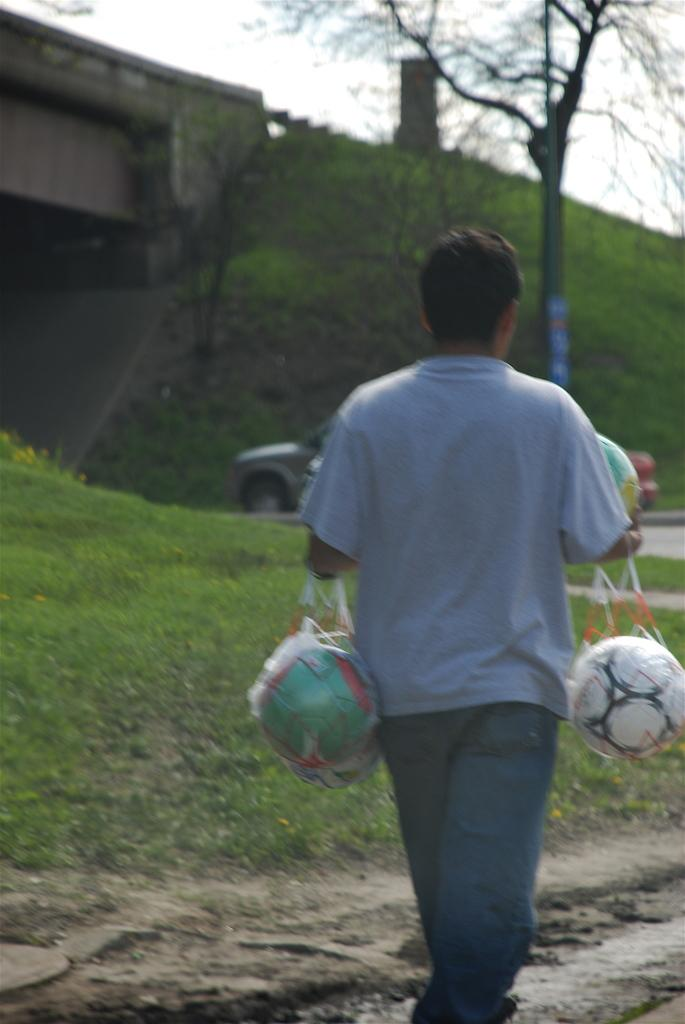What is the person in the image doing? The person is walking in the image. What is the person holding while walking? The person is holding a ball. What type of terrain is visible in the image? There is grass visible in the image. What type of structure can be seen in the image? There is a bridge in the image. What type of plant is present in the image? There is a tree in the image. What is visible in the background of the image? The sky is visible in the image. What type of coal can be seen in the image? There is no coal present in the image. Can you spot a giraffe in the image? There is no giraffe present in the image. 